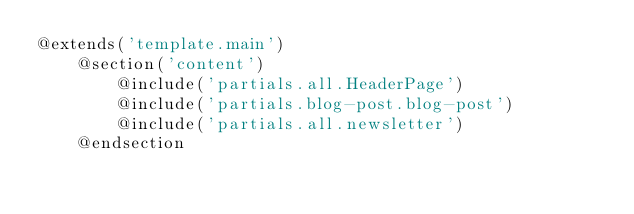Convert code to text. <code><loc_0><loc_0><loc_500><loc_500><_PHP_>@extends('template.main')
    @section('content')
        @include('partials.all.HeaderPage')
        @include('partials.blog-post.blog-post')
        @include('partials.all.newsletter')
    @endsection</code> 